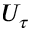Convert formula to latex. <formula><loc_0><loc_0><loc_500><loc_500>U _ { \tau }</formula> 